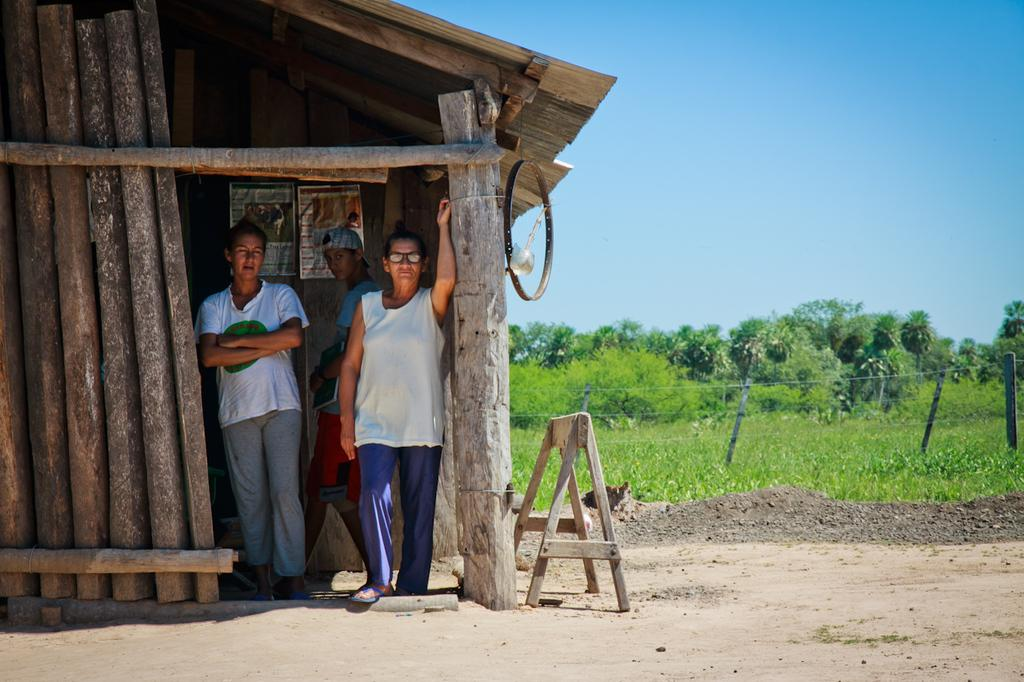How many people are in the image? There are three people in the image. What structure can be seen in the image? There is a shed in the image. What objects are present in the image that might be used for support or stability? There are poles in the image. What object in the image might be used for transportation or movement? There is a wheel in the image. What type of wooden object is visible in the image? There is a wooden object in the image, but it is not specified what kind of object it is. What type of vegetation is present in the image? There are plants in the image. What type of barrier can be seen in the image? There is a fence in the image. What type of natural feature is visible in the background of the image? There are trees in the background of the image, but there is no boundary or credit mentioned in the image. What type of jewel is being used as a boundary in the image? There is no jewel or boundary present in the image. What type of credit card is being used to pay for the wooden object in the image? There is no credit card or payment mentioned in the image. 